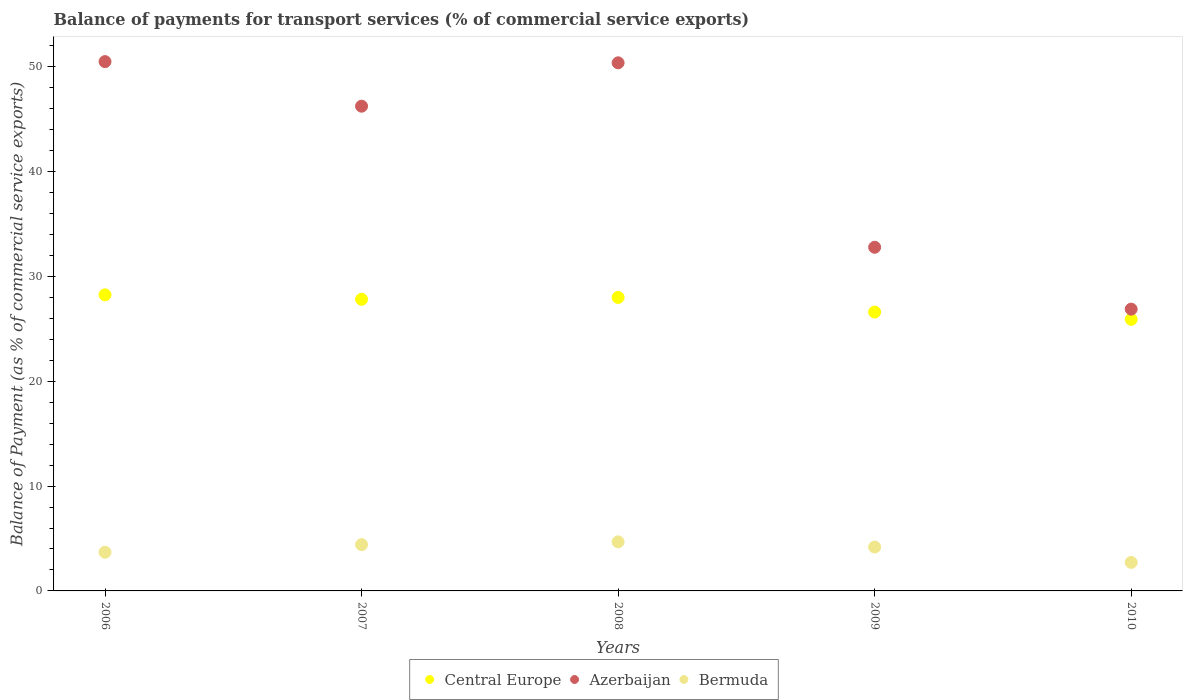How many different coloured dotlines are there?
Provide a succinct answer. 3. What is the balance of payments for transport services in Azerbaijan in 2007?
Ensure brevity in your answer.  46.25. Across all years, what is the maximum balance of payments for transport services in Azerbaijan?
Offer a terse response. 50.5. Across all years, what is the minimum balance of payments for transport services in Central Europe?
Make the answer very short. 25.91. In which year was the balance of payments for transport services in Central Europe maximum?
Give a very brief answer. 2006. In which year was the balance of payments for transport services in Azerbaijan minimum?
Offer a very short reply. 2010. What is the total balance of payments for transport services in Azerbaijan in the graph?
Make the answer very short. 206.81. What is the difference between the balance of payments for transport services in Bermuda in 2006 and that in 2010?
Give a very brief answer. 0.97. What is the difference between the balance of payments for transport services in Bermuda in 2007 and the balance of payments for transport services in Azerbaijan in 2009?
Your response must be concise. -28.37. What is the average balance of payments for transport services in Central Europe per year?
Provide a short and direct response. 27.32. In the year 2006, what is the difference between the balance of payments for transport services in Bermuda and balance of payments for transport services in Azerbaijan?
Your answer should be very brief. -46.81. In how many years, is the balance of payments for transport services in Bermuda greater than 10 %?
Give a very brief answer. 0. What is the ratio of the balance of payments for transport services in Azerbaijan in 2007 to that in 2009?
Offer a terse response. 1.41. Is the balance of payments for transport services in Central Europe in 2006 less than that in 2009?
Keep it short and to the point. No. What is the difference between the highest and the second highest balance of payments for transport services in Azerbaijan?
Your answer should be very brief. 0.12. What is the difference between the highest and the lowest balance of payments for transport services in Azerbaijan?
Ensure brevity in your answer.  23.62. In how many years, is the balance of payments for transport services in Azerbaijan greater than the average balance of payments for transport services in Azerbaijan taken over all years?
Give a very brief answer. 3. Is it the case that in every year, the sum of the balance of payments for transport services in Central Europe and balance of payments for transport services in Azerbaijan  is greater than the balance of payments for transport services in Bermuda?
Offer a very short reply. Yes. Is the balance of payments for transport services in Central Europe strictly less than the balance of payments for transport services in Azerbaijan over the years?
Offer a terse response. Yes. How many dotlines are there?
Offer a terse response. 3. Does the graph contain any zero values?
Make the answer very short. No. What is the title of the graph?
Provide a short and direct response. Balance of payments for transport services (% of commercial service exports). Does "San Marino" appear as one of the legend labels in the graph?
Your response must be concise. No. What is the label or title of the X-axis?
Ensure brevity in your answer.  Years. What is the label or title of the Y-axis?
Offer a very short reply. Balance of Payment (as % of commercial service exports). What is the Balance of Payment (as % of commercial service exports) of Central Europe in 2006?
Provide a short and direct response. 28.25. What is the Balance of Payment (as % of commercial service exports) in Azerbaijan in 2006?
Provide a short and direct response. 50.5. What is the Balance of Payment (as % of commercial service exports) in Bermuda in 2006?
Provide a short and direct response. 3.69. What is the Balance of Payment (as % of commercial service exports) of Central Europe in 2007?
Your answer should be very brief. 27.82. What is the Balance of Payment (as % of commercial service exports) of Azerbaijan in 2007?
Make the answer very short. 46.25. What is the Balance of Payment (as % of commercial service exports) in Bermuda in 2007?
Your answer should be compact. 4.42. What is the Balance of Payment (as % of commercial service exports) in Central Europe in 2008?
Your answer should be compact. 28. What is the Balance of Payment (as % of commercial service exports) in Azerbaijan in 2008?
Offer a very short reply. 50.39. What is the Balance of Payment (as % of commercial service exports) in Bermuda in 2008?
Provide a succinct answer. 4.68. What is the Balance of Payment (as % of commercial service exports) in Central Europe in 2009?
Your answer should be compact. 26.61. What is the Balance of Payment (as % of commercial service exports) of Azerbaijan in 2009?
Your answer should be very brief. 32.79. What is the Balance of Payment (as % of commercial service exports) of Bermuda in 2009?
Give a very brief answer. 4.19. What is the Balance of Payment (as % of commercial service exports) in Central Europe in 2010?
Offer a terse response. 25.91. What is the Balance of Payment (as % of commercial service exports) of Azerbaijan in 2010?
Provide a succinct answer. 26.89. What is the Balance of Payment (as % of commercial service exports) of Bermuda in 2010?
Keep it short and to the point. 2.72. Across all years, what is the maximum Balance of Payment (as % of commercial service exports) in Central Europe?
Your response must be concise. 28.25. Across all years, what is the maximum Balance of Payment (as % of commercial service exports) in Azerbaijan?
Give a very brief answer. 50.5. Across all years, what is the maximum Balance of Payment (as % of commercial service exports) of Bermuda?
Provide a short and direct response. 4.68. Across all years, what is the minimum Balance of Payment (as % of commercial service exports) in Central Europe?
Make the answer very short. 25.91. Across all years, what is the minimum Balance of Payment (as % of commercial service exports) in Azerbaijan?
Give a very brief answer. 26.89. Across all years, what is the minimum Balance of Payment (as % of commercial service exports) in Bermuda?
Keep it short and to the point. 2.72. What is the total Balance of Payment (as % of commercial service exports) in Central Europe in the graph?
Provide a succinct answer. 136.6. What is the total Balance of Payment (as % of commercial service exports) of Azerbaijan in the graph?
Offer a terse response. 206.81. What is the total Balance of Payment (as % of commercial service exports) of Bermuda in the graph?
Ensure brevity in your answer.  19.7. What is the difference between the Balance of Payment (as % of commercial service exports) of Central Europe in 2006 and that in 2007?
Your answer should be very brief. 0.43. What is the difference between the Balance of Payment (as % of commercial service exports) of Azerbaijan in 2006 and that in 2007?
Your response must be concise. 4.25. What is the difference between the Balance of Payment (as % of commercial service exports) in Bermuda in 2006 and that in 2007?
Provide a succinct answer. -0.73. What is the difference between the Balance of Payment (as % of commercial service exports) in Central Europe in 2006 and that in 2008?
Keep it short and to the point. 0.25. What is the difference between the Balance of Payment (as % of commercial service exports) of Azerbaijan in 2006 and that in 2008?
Make the answer very short. 0.12. What is the difference between the Balance of Payment (as % of commercial service exports) in Bermuda in 2006 and that in 2008?
Offer a very short reply. -0.99. What is the difference between the Balance of Payment (as % of commercial service exports) of Central Europe in 2006 and that in 2009?
Make the answer very short. 1.64. What is the difference between the Balance of Payment (as % of commercial service exports) in Azerbaijan in 2006 and that in 2009?
Offer a very short reply. 17.71. What is the difference between the Balance of Payment (as % of commercial service exports) of Bermuda in 2006 and that in 2009?
Provide a succinct answer. -0.5. What is the difference between the Balance of Payment (as % of commercial service exports) in Central Europe in 2006 and that in 2010?
Your response must be concise. 2.34. What is the difference between the Balance of Payment (as % of commercial service exports) in Azerbaijan in 2006 and that in 2010?
Ensure brevity in your answer.  23.62. What is the difference between the Balance of Payment (as % of commercial service exports) of Bermuda in 2006 and that in 2010?
Ensure brevity in your answer.  0.97. What is the difference between the Balance of Payment (as % of commercial service exports) in Central Europe in 2007 and that in 2008?
Your response must be concise. -0.18. What is the difference between the Balance of Payment (as % of commercial service exports) in Azerbaijan in 2007 and that in 2008?
Give a very brief answer. -4.14. What is the difference between the Balance of Payment (as % of commercial service exports) in Bermuda in 2007 and that in 2008?
Ensure brevity in your answer.  -0.27. What is the difference between the Balance of Payment (as % of commercial service exports) of Central Europe in 2007 and that in 2009?
Give a very brief answer. 1.22. What is the difference between the Balance of Payment (as % of commercial service exports) in Azerbaijan in 2007 and that in 2009?
Your answer should be compact. 13.46. What is the difference between the Balance of Payment (as % of commercial service exports) in Bermuda in 2007 and that in 2009?
Make the answer very short. 0.23. What is the difference between the Balance of Payment (as % of commercial service exports) in Central Europe in 2007 and that in 2010?
Your answer should be very brief. 1.91. What is the difference between the Balance of Payment (as % of commercial service exports) of Azerbaijan in 2007 and that in 2010?
Ensure brevity in your answer.  19.36. What is the difference between the Balance of Payment (as % of commercial service exports) of Bermuda in 2007 and that in 2010?
Make the answer very short. 1.69. What is the difference between the Balance of Payment (as % of commercial service exports) of Central Europe in 2008 and that in 2009?
Your response must be concise. 1.39. What is the difference between the Balance of Payment (as % of commercial service exports) in Azerbaijan in 2008 and that in 2009?
Keep it short and to the point. 17.6. What is the difference between the Balance of Payment (as % of commercial service exports) in Bermuda in 2008 and that in 2009?
Keep it short and to the point. 0.49. What is the difference between the Balance of Payment (as % of commercial service exports) in Central Europe in 2008 and that in 2010?
Make the answer very short. 2.09. What is the difference between the Balance of Payment (as % of commercial service exports) in Azerbaijan in 2008 and that in 2010?
Ensure brevity in your answer.  23.5. What is the difference between the Balance of Payment (as % of commercial service exports) of Bermuda in 2008 and that in 2010?
Offer a very short reply. 1.96. What is the difference between the Balance of Payment (as % of commercial service exports) in Central Europe in 2009 and that in 2010?
Make the answer very short. 0.69. What is the difference between the Balance of Payment (as % of commercial service exports) of Azerbaijan in 2009 and that in 2010?
Your response must be concise. 5.9. What is the difference between the Balance of Payment (as % of commercial service exports) in Bermuda in 2009 and that in 2010?
Provide a succinct answer. 1.47. What is the difference between the Balance of Payment (as % of commercial service exports) in Central Europe in 2006 and the Balance of Payment (as % of commercial service exports) in Azerbaijan in 2007?
Ensure brevity in your answer.  -18. What is the difference between the Balance of Payment (as % of commercial service exports) in Central Europe in 2006 and the Balance of Payment (as % of commercial service exports) in Bermuda in 2007?
Offer a very short reply. 23.83. What is the difference between the Balance of Payment (as % of commercial service exports) in Azerbaijan in 2006 and the Balance of Payment (as % of commercial service exports) in Bermuda in 2007?
Provide a short and direct response. 46.09. What is the difference between the Balance of Payment (as % of commercial service exports) in Central Europe in 2006 and the Balance of Payment (as % of commercial service exports) in Azerbaijan in 2008?
Offer a very short reply. -22.14. What is the difference between the Balance of Payment (as % of commercial service exports) in Central Europe in 2006 and the Balance of Payment (as % of commercial service exports) in Bermuda in 2008?
Your answer should be compact. 23.57. What is the difference between the Balance of Payment (as % of commercial service exports) of Azerbaijan in 2006 and the Balance of Payment (as % of commercial service exports) of Bermuda in 2008?
Your answer should be very brief. 45.82. What is the difference between the Balance of Payment (as % of commercial service exports) of Central Europe in 2006 and the Balance of Payment (as % of commercial service exports) of Azerbaijan in 2009?
Ensure brevity in your answer.  -4.54. What is the difference between the Balance of Payment (as % of commercial service exports) in Central Europe in 2006 and the Balance of Payment (as % of commercial service exports) in Bermuda in 2009?
Keep it short and to the point. 24.06. What is the difference between the Balance of Payment (as % of commercial service exports) in Azerbaijan in 2006 and the Balance of Payment (as % of commercial service exports) in Bermuda in 2009?
Offer a terse response. 46.31. What is the difference between the Balance of Payment (as % of commercial service exports) of Central Europe in 2006 and the Balance of Payment (as % of commercial service exports) of Azerbaijan in 2010?
Offer a terse response. 1.36. What is the difference between the Balance of Payment (as % of commercial service exports) of Central Europe in 2006 and the Balance of Payment (as % of commercial service exports) of Bermuda in 2010?
Keep it short and to the point. 25.53. What is the difference between the Balance of Payment (as % of commercial service exports) of Azerbaijan in 2006 and the Balance of Payment (as % of commercial service exports) of Bermuda in 2010?
Keep it short and to the point. 47.78. What is the difference between the Balance of Payment (as % of commercial service exports) of Central Europe in 2007 and the Balance of Payment (as % of commercial service exports) of Azerbaijan in 2008?
Give a very brief answer. -22.56. What is the difference between the Balance of Payment (as % of commercial service exports) of Central Europe in 2007 and the Balance of Payment (as % of commercial service exports) of Bermuda in 2008?
Offer a very short reply. 23.14. What is the difference between the Balance of Payment (as % of commercial service exports) in Azerbaijan in 2007 and the Balance of Payment (as % of commercial service exports) in Bermuda in 2008?
Your answer should be very brief. 41.57. What is the difference between the Balance of Payment (as % of commercial service exports) in Central Europe in 2007 and the Balance of Payment (as % of commercial service exports) in Azerbaijan in 2009?
Provide a short and direct response. -4.96. What is the difference between the Balance of Payment (as % of commercial service exports) of Central Europe in 2007 and the Balance of Payment (as % of commercial service exports) of Bermuda in 2009?
Offer a very short reply. 23.64. What is the difference between the Balance of Payment (as % of commercial service exports) of Azerbaijan in 2007 and the Balance of Payment (as % of commercial service exports) of Bermuda in 2009?
Provide a short and direct response. 42.06. What is the difference between the Balance of Payment (as % of commercial service exports) of Central Europe in 2007 and the Balance of Payment (as % of commercial service exports) of Azerbaijan in 2010?
Your response must be concise. 0.94. What is the difference between the Balance of Payment (as % of commercial service exports) of Central Europe in 2007 and the Balance of Payment (as % of commercial service exports) of Bermuda in 2010?
Ensure brevity in your answer.  25.1. What is the difference between the Balance of Payment (as % of commercial service exports) in Azerbaijan in 2007 and the Balance of Payment (as % of commercial service exports) in Bermuda in 2010?
Provide a short and direct response. 43.53. What is the difference between the Balance of Payment (as % of commercial service exports) in Central Europe in 2008 and the Balance of Payment (as % of commercial service exports) in Azerbaijan in 2009?
Your answer should be compact. -4.79. What is the difference between the Balance of Payment (as % of commercial service exports) of Central Europe in 2008 and the Balance of Payment (as % of commercial service exports) of Bermuda in 2009?
Give a very brief answer. 23.81. What is the difference between the Balance of Payment (as % of commercial service exports) of Azerbaijan in 2008 and the Balance of Payment (as % of commercial service exports) of Bermuda in 2009?
Your answer should be very brief. 46.2. What is the difference between the Balance of Payment (as % of commercial service exports) of Central Europe in 2008 and the Balance of Payment (as % of commercial service exports) of Azerbaijan in 2010?
Provide a short and direct response. 1.12. What is the difference between the Balance of Payment (as % of commercial service exports) in Central Europe in 2008 and the Balance of Payment (as % of commercial service exports) in Bermuda in 2010?
Provide a succinct answer. 25.28. What is the difference between the Balance of Payment (as % of commercial service exports) in Azerbaijan in 2008 and the Balance of Payment (as % of commercial service exports) in Bermuda in 2010?
Give a very brief answer. 47.66. What is the difference between the Balance of Payment (as % of commercial service exports) of Central Europe in 2009 and the Balance of Payment (as % of commercial service exports) of Azerbaijan in 2010?
Ensure brevity in your answer.  -0.28. What is the difference between the Balance of Payment (as % of commercial service exports) in Central Europe in 2009 and the Balance of Payment (as % of commercial service exports) in Bermuda in 2010?
Offer a terse response. 23.89. What is the difference between the Balance of Payment (as % of commercial service exports) of Azerbaijan in 2009 and the Balance of Payment (as % of commercial service exports) of Bermuda in 2010?
Your response must be concise. 30.07. What is the average Balance of Payment (as % of commercial service exports) in Central Europe per year?
Your answer should be very brief. 27.32. What is the average Balance of Payment (as % of commercial service exports) in Azerbaijan per year?
Keep it short and to the point. 41.36. What is the average Balance of Payment (as % of commercial service exports) of Bermuda per year?
Your answer should be very brief. 3.94. In the year 2006, what is the difference between the Balance of Payment (as % of commercial service exports) in Central Europe and Balance of Payment (as % of commercial service exports) in Azerbaijan?
Give a very brief answer. -22.25. In the year 2006, what is the difference between the Balance of Payment (as % of commercial service exports) in Central Europe and Balance of Payment (as % of commercial service exports) in Bermuda?
Give a very brief answer. 24.56. In the year 2006, what is the difference between the Balance of Payment (as % of commercial service exports) in Azerbaijan and Balance of Payment (as % of commercial service exports) in Bermuda?
Your answer should be very brief. 46.81. In the year 2007, what is the difference between the Balance of Payment (as % of commercial service exports) in Central Europe and Balance of Payment (as % of commercial service exports) in Azerbaijan?
Provide a short and direct response. -18.42. In the year 2007, what is the difference between the Balance of Payment (as % of commercial service exports) in Central Europe and Balance of Payment (as % of commercial service exports) in Bermuda?
Offer a very short reply. 23.41. In the year 2007, what is the difference between the Balance of Payment (as % of commercial service exports) of Azerbaijan and Balance of Payment (as % of commercial service exports) of Bermuda?
Your answer should be very brief. 41.83. In the year 2008, what is the difference between the Balance of Payment (as % of commercial service exports) of Central Europe and Balance of Payment (as % of commercial service exports) of Azerbaijan?
Provide a short and direct response. -22.39. In the year 2008, what is the difference between the Balance of Payment (as % of commercial service exports) of Central Europe and Balance of Payment (as % of commercial service exports) of Bermuda?
Provide a short and direct response. 23.32. In the year 2008, what is the difference between the Balance of Payment (as % of commercial service exports) in Azerbaijan and Balance of Payment (as % of commercial service exports) in Bermuda?
Keep it short and to the point. 45.7. In the year 2009, what is the difference between the Balance of Payment (as % of commercial service exports) in Central Europe and Balance of Payment (as % of commercial service exports) in Azerbaijan?
Your response must be concise. -6.18. In the year 2009, what is the difference between the Balance of Payment (as % of commercial service exports) of Central Europe and Balance of Payment (as % of commercial service exports) of Bermuda?
Give a very brief answer. 22.42. In the year 2009, what is the difference between the Balance of Payment (as % of commercial service exports) in Azerbaijan and Balance of Payment (as % of commercial service exports) in Bermuda?
Offer a very short reply. 28.6. In the year 2010, what is the difference between the Balance of Payment (as % of commercial service exports) of Central Europe and Balance of Payment (as % of commercial service exports) of Azerbaijan?
Give a very brief answer. -0.97. In the year 2010, what is the difference between the Balance of Payment (as % of commercial service exports) in Central Europe and Balance of Payment (as % of commercial service exports) in Bermuda?
Your response must be concise. 23.19. In the year 2010, what is the difference between the Balance of Payment (as % of commercial service exports) of Azerbaijan and Balance of Payment (as % of commercial service exports) of Bermuda?
Provide a short and direct response. 24.16. What is the ratio of the Balance of Payment (as % of commercial service exports) in Central Europe in 2006 to that in 2007?
Your answer should be compact. 1.02. What is the ratio of the Balance of Payment (as % of commercial service exports) of Azerbaijan in 2006 to that in 2007?
Provide a succinct answer. 1.09. What is the ratio of the Balance of Payment (as % of commercial service exports) in Bermuda in 2006 to that in 2007?
Provide a short and direct response. 0.84. What is the ratio of the Balance of Payment (as % of commercial service exports) in Central Europe in 2006 to that in 2008?
Offer a terse response. 1.01. What is the ratio of the Balance of Payment (as % of commercial service exports) of Azerbaijan in 2006 to that in 2008?
Make the answer very short. 1. What is the ratio of the Balance of Payment (as % of commercial service exports) of Bermuda in 2006 to that in 2008?
Ensure brevity in your answer.  0.79. What is the ratio of the Balance of Payment (as % of commercial service exports) of Central Europe in 2006 to that in 2009?
Give a very brief answer. 1.06. What is the ratio of the Balance of Payment (as % of commercial service exports) in Azerbaijan in 2006 to that in 2009?
Your response must be concise. 1.54. What is the ratio of the Balance of Payment (as % of commercial service exports) of Bermuda in 2006 to that in 2009?
Your answer should be compact. 0.88. What is the ratio of the Balance of Payment (as % of commercial service exports) of Central Europe in 2006 to that in 2010?
Give a very brief answer. 1.09. What is the ratio of the Balance of Payment (as % of commercial service exports) of Azerbaijan in 2006 to that in 2010?
Your answer should be compact. 1.88. What is the ratio of the Balance of Payment (as % of commercial service exports) of Bermuda in 2006 to that in 2010?
Your response must be concise. 1.36. What is the ratio of the Balance of Payment (as % of commercial service exports) of Azerbaijan in 2007 to that in 2008?
Make the answer very short. 0.92. What is the ratio of the Balance of Payment (as % of commercial service exports) in Bermuda in 2007 to that in 2008?
Keep it short and to the point. 0.94. What is the ratio of the Balance of Payment (as % of commercial service exports) of Central Europe in 2007 to that in 2009?
Give a very brief answer. 1.05. What is the ratio of the Balance of Payment (as % of commercial service exports) of Azerbaijan in 2007 to that in 2009?
Keep it short and to the point. 1.41. What is the ratio of the Balance of Payment (as % of commercial service exports) of Bermuda in 2007 to that in 2009?
Your answer should be compact. 1.05. What is the ratio of the Balance of Payment (as % of commercial service exports) of Central Europe in 2007 to that in 2010?
Offer a terse response. 1.07. What is the ratio of the Balance of Payment (as % of commercial service exports) in Azerbaijan in 2007 to that in 2010?
Provide a short and direct response. 1.72. What is the ratio of the Balance of Payment (as % of commercial service exports) of Bermuda in 2007 to that in 2010?
Provide a short and direct response. 1.62. What is the ratio of the Balance of Payment (as % of commercial service exports) of Central Europe in 2008 to that in 2009?
Provide a succinct answer. 1.05. What is the ratio of the Balance of Payment (as % of commercial service exports) of Azerbaijan in 2008 to that in 2009?
Ensure brevity in your answer.  1.54. What is the ratio of the Balance of Payment (as % of commercial service exports) of Bermuda in 2008 to that in 2009?
Give a very brief answer. 1.12. What is the ratio of the Balance of Payment (as % of commercial service exports) in Central Europe in 2008 to that in 2010?
Make the answer very short. 1.08. What is the ratio of the Balance of Payment (as % of commercial service exports) in Azerbaijan in 2008 to that in 2010?
Make the answer very short. 1.87. What is the ratio of the Balance of Payment (as % of commercial service exports) of Bermuda in 2008 to that in 2010?
Provide a succinct answer. 1.72. What is the ratio of the Balance of Payment (as % of commercial service exports) of Central Europe in 2009 to that in 2010?
Offer a terse response. 1.03. What is the ratio of the Balance of Payment (as % of commercial service exports) of Azerbaijan in 2009 to that in 2010?
Make the answer very short. 1.22. What is the ratio of the Balance of Payment (as % of commercial service exports) of Bermuda in 2009 to that in 2010?
Provide a succinct answer. 1.54. What is the difference between the highest and the second highest Balance of Payment (as % of commercial service exports) in Central Europe?
Offer a very short reply. 0.25. What is the difference between the highest and the second highest Balance of Payment (as % of commercial service exports) of Azerbaijan?
Give a very brief answer. 0.12. What is the difference between the highest and the second highest Balance of Payment (as % of commercial service exports) of Bermuda?
Keep it short and to the point. 0.27. What is the difference between the highest and the lowest Balance of Payment (as % of commercial service exports) in Central Europe?
Provide a succinct answer. 2.34. What is the difference between the highest and the lowest Balance of Payment (as % of commercial service exports) of Azerbaijan?
Offer a terse response. 23.62. What is the difference between the highest and the lowest Balance of Payment (as % of commercial service exports) of Bermuda?
Ensure brevity in your answer.  1.96. 